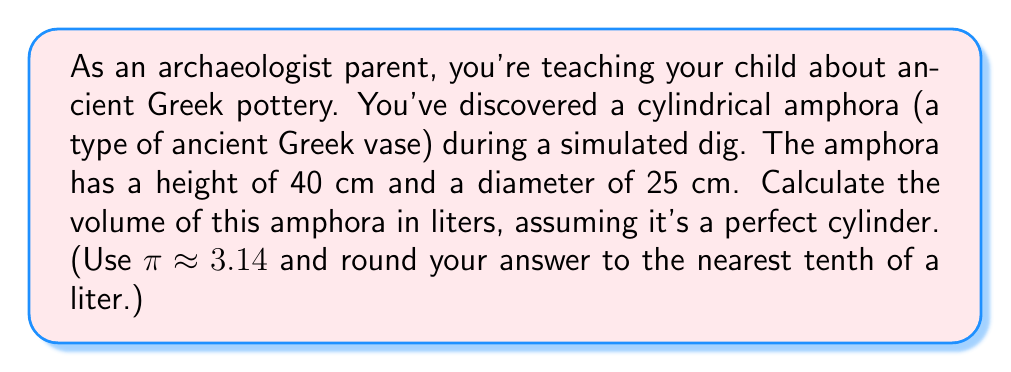Help me with this question. To calculate the volume of the cylindrical amphora, we'll use the formula for the volume of a cylinder:

$$V = \pi r^2 h$$

Where:
$V$ = volume
$r$ = radius of the base
$h$ = height of the cylinder

Let's break this down step-by-step:

1. Identify the given measurements:
   - Height (h) = 40 cm
   - Diameter = 25 cm

2. Calculate the radius:
   $r = \frac{\text{diameter}}{2} = \frac{25 \text{ cm}}{2} = 12.5 \text{ cm}$

3. Apply the volume formula:
   $$V = \pi r^2 h$$
   $$V = 3.14 \times (12.5 \text{ cm})^2 \times 40 \text{ cm}$$

4. Calculate:
   $$V = 3.14 \times 156.25 \text{ cm}^2 \times 40 \text{ cm}$$
   $$V = 19,625 \text{ cm}^3$$

5. Convert cubic centimeters to liters:
   1 liter = 1000 cm³, so:
   $$V = \frac{19,625 \text{ cm}^3}{1000 \text{ cm}^3/L} = 19.625 \text{ L}$$

6. Round to the nearest tenth of a liter:
   19.625 L ≈ 19.6 L
Answer: The volume of the amphora is approximately 19.6 liters. 